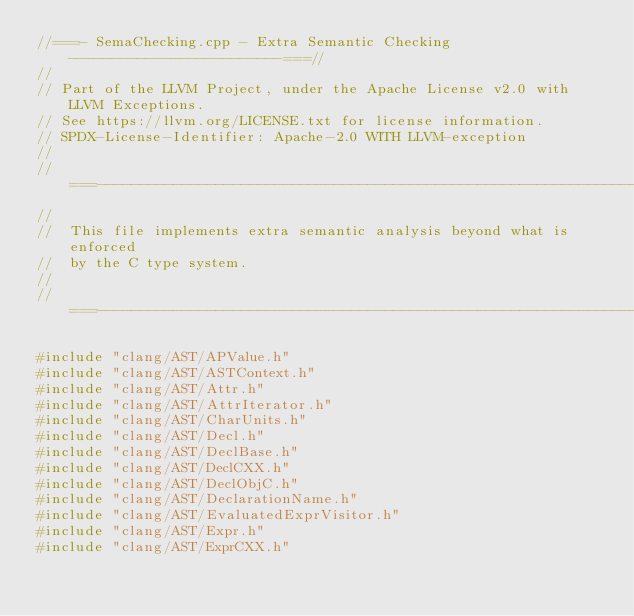Convert code to text. <code><loc_0><loc_0><loc_500><loc_500><_C++_>//===- SemaChecking.cpp - Extra Semantic Checking -------------------------===//
//
// Part of the LLVM Project, under the Apache License v2.0 with LLVM Exceptions.
// See https://llvm.org/LICENSE.txt for license information.
// SPDX-License-Identifier: Apache-2.0 WITH LLVM-exception
//
//===----------------------------------------------------------------------===//
//
//  This file implements extra semantic analysis beyond what is enforced
//  by the C type system.
//
//===----------------------------------------------------------------------===//

#include "clang/AST/APValue.h"
#include "clang/AST/ASTContext.h"
#include "clang/AST/Attr.h"
#include "clang/AST/AttrIterator.h"
#include "clang/AST/CharUnits.h"
#include "clang/AST/Decl.h"
#include "clang/AST/DeclBase.h"
#include "clang/AST/DeclCXX.h"
#include "clang/AST/DeclObjC.h"
#include "clang/AST/DeclarationName.h"
#include "clang/AST/EvaluatedExprVisitor.h"
#include "clang/AST/Expr.h"
#include "clang/AST/ExprCXX.h"</code> 